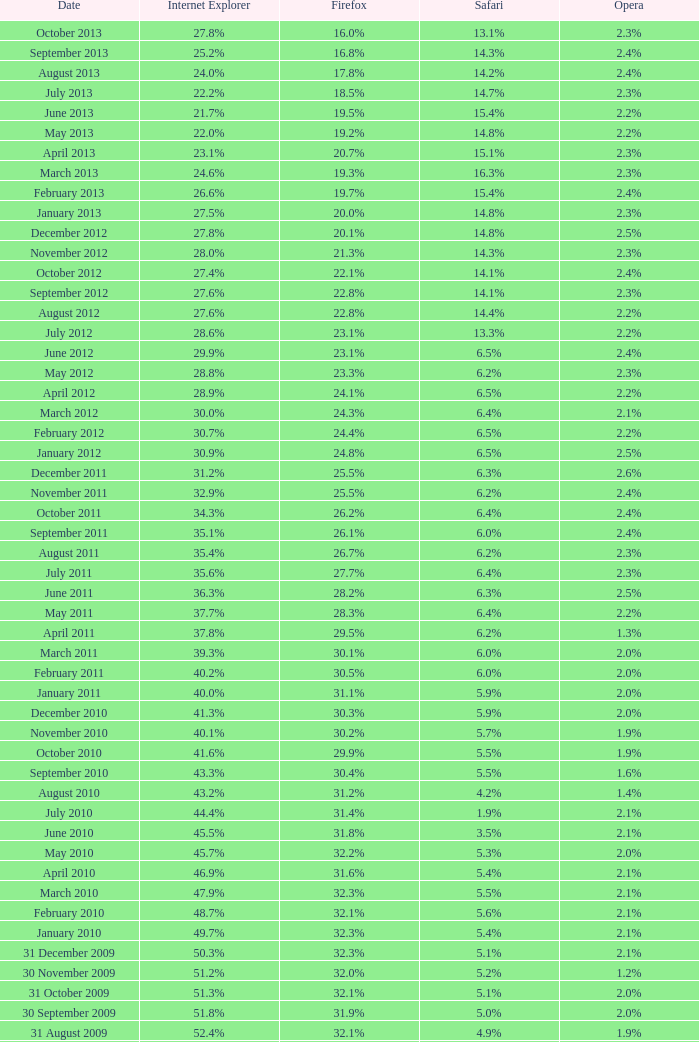Could you parse the entire table as a dict? {'header': ['Date', 'Internet Explorer', 'Firefox', 'Safari', 'Opera'], 'rows': [['October 2013', '27.8%', '16.0%', '13.1%', '2.3%'], ['September 2013', '25.2%', '16.8%', '14.3%', '2.4%'], ['August 2013', '24.0%', '17.8%', '14.2%', '2.4%'], ['July 2013', '22.2%', '18.5%', '14.7%', '2.3%'], ['June 2013', '21.7%', '19.5%', '15.4%', '2.2%'], ['May 2013', '22.0%', '19.2%', '14.8%', '2.2%'], ['April 2013', '23.1%', '20.7%', '15.1%', '2.3%'], ['March 2013', '24.6%', '19.3%', '16.3%', '2.3%'], ['February 2013', '26.6%', '19.7%', '15.4%', '2.4%'], ['January 2013', '27.5%', '20.0%', '14.8%', '2.3%'], ['December 2012', '27.8%', '20.1%', '14.8%', '2.5%'], ['November 2012', '28.0%', '21.3%', '14.3%', '2.3%'], ['October 2012', '27.4%', '22.1%', '14.1%', '2.4%'], ['September 2012', '27.6%', '22.8%', '14.1%', '2.3%'], ['August 2012', '27.6%', '22.8%', '14.4%', '2.2%'], ['July 2012', '28.6%', '23.1%', '13.3%', '2.2%'], ['June 2012', '29.9%', '23.1%', '6.5%', '2.4%'], ['May 2012', '28.8%', '23.3%', '6.2%', '2.3%'], ['April 2012', '28.9%', '24.1%', '6.5%', '2.2%'], ['March 2012', '30.0%', '24.3%', '6.4%', '2.1%'], ['February 2012', '30.7%', '24.4%', '6.5%', '2.2%'], ['January 2012', '30.9%', '24.8%', '6.5%', '2.5%'], ['December 2011', '31.2%', '25.5%', '6.3%', '2.6%'], ['November 2011', '32.9%', '25.5%', '6.2%', '2.4%'], ['October 2011', '34.3%', '26.2%', '6.4%', '2.4%'], ['September 2011', '35.1%', '26.1%', '6.0%', '2.4%'], ['August 2011', '35.4%', '26.7%', '6.2%', '2.3%'], ['July 2011', '35.6%', '27.7%', '6.4%', '2.3%'], ['June 2011', '36.3%', '28.2%', '6.3%', '2.5%'], ['May 2011', '37.7%', '28.3%', '6.4%', '2.2%'], ['April 2011', '37.8%', '29.5%', '6.2%', '1.3%'], ['March 2011', '39.3%', '30.1%', '6.0%', '2.0%'], ['February 2011', '40.2%', '30.5%', '6.0%', '2.0%'], ['January 2011', '40.0%', '31.1%', '5.9%', '2.0%'], ['December 2010', '41.3%', '30.3%', '5.9%', '2.0%'], ['November 2010', '40.1%', '30.2%', '5.7%', '1.9%'], ['October 2010', '41.6%', '29.9%', '5.5%', '1.9%'], ['September 2010', '43.3%', '30.4%', '5.5%', '1.6%'], ['August 2010', '43.2%', '31.2%', '4.2%', '1.4%'], ['July 2010', '44.4%', '31.4%', '1.9%', '2.1%'], ['June 2010', '45.5%', '31.8%', '3.5%', '2.1%'], ['May 2010', '45.7%', '32.2%', '5.3%', '2.0%'], ['April 2010', '46.9%', '31.6%', '5.4%', '2.1%'], ['March 2010', '47.9%', '32.3%', '5.5%', '2.1%'], ['February 2010', '48.7%', '32.1%', '5.6%', '2.1%'], ['January 2010', '49.7%', '32.3%', '5.4%', '2.1%'], ['31 December 2009', '50.3%', '32.3%', '5.1%', '2.1%'], ['30 November 2009', '51.2%', '32.0%', '5.2%', '1.2%'], ['31 October 2009', '51.3%', '32.1%', '5.1%', '2.0%'], ['30 September 2009', '51.8%', '31.9%', '5.0%', '2.0%'], ['31 August 2009', '52.4%', '32.1%', '4.9%', '1.9%'], ['31 July 2009', '53.1%', '31.7%', '4.6%', '1.8%'], ['30 June 2009', '57.1%', '31.6%', '3.2%', '2.0%'], ['31 May 2009', '57.5%', '31.4%', '3.1%', '2.0%'], ['30 April 2009', '57.6%', '31.6%', '2.9%', '2.0%'], ['31 March 2009', '57.8%', '31.5%', '2.8%', '2.0%'], ['28 February 2009', '58.1%', '31.3%', '2.7%', '2.0%'], ['31 January 2009', '58.4%', '31.1%', '2.7%', '2.0%'], ['31 December 2008', '58.6%', '31.1%', '2.9%', '2.1%'], ['30 November 2008', '59.0%', '30.8%', '3.0%', '2.0%'], ['31 October 2008', '59.4%', '30.6%', '3.0%', '2.0%'], ['30 September 2008', '57.3%', '32.5%', '2.7%', '2.0%'], ['31 August 2008', '58.7%', '31.4%', '2.4%', '2.1%'], ['31 July 2008', '60.9%', '29.7%', '2.4%', '2.0%'], ['30 June 2008', '61.7%', '29.1%', '2.5%', '2.0%'], ['31 May 2008', '61.9%', '28.9%', '2.7%', '2.0%'], ['30 April 2008', '62.0%', '28.8%', '2.8%', '2.0%'], ['31 March 2008', '62.0%', '28.8%', '2.8%', '2.0%'], ['29 February 2008', '62.0%', '28.7%', '2.8%', '2.0%'], ['31 January 2008', '62.2%', '28.7%', '2.7%', '2.0%'], ['1 December 2007', '62.8%', '28.0%', '2.6%', '2.0%'], ['10 November 2007', '63.0%', '27.8%', '2.5%', '2.0%'], ['30 October 2007', '65.5%', '26.3%', '2.3%', '1.8%'], ['20 September 2007', '66.6%', '25.6%', '2.1%', '1.8%'], ['30 August 2007', '66.7%', '25.5%', '2.1%', '1.8%'], ['30 July 2007', '66.9%', '25.1%', '2.2%', '1.8%'], ['30 June 2007', '66.9%', '25.1%', '2.3%', '1.8%'], ['30 May 2007', '67.1%', '24.8%', '2.4%', '1.8%'], ['Date', 'Internet Explorer', 'Firefox', 'Safari', 'Opera']]} 9% safari? 31.4%. 